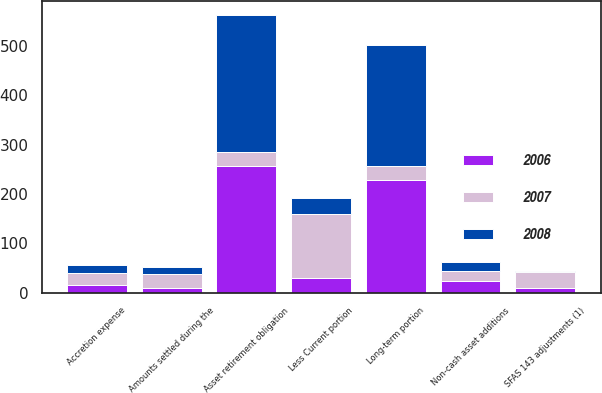Convert chart to OTSL. <chart><loc_0><loc_0><loc_500><loc_500><stacked_bar_chart><ecel><fcel>Asset retirement obligation<fcel>Non-cash asset additions<fcel>SFAS 143 adjustments (1)<fcel>Amounts settled during the<fcel>Accretion expense<fcel>Less Current portion<fcel>Long-term portion<nl><fcel>2007<fcel>28.45<fcel>20.5<fcel>32.6<fcel>27.9<fcel>23.9<fcel>130.6<fcel>28.45<nl><fcel>2008<fcel>277.7<fcel>19.5<fcel>1.8<fcel>14.7<fcel>17.1<fcel>32.6<fcel>245.1<nl><fcel>2006<fcel>257.6<fcel>22.8<fcel>10<fcel>10.4<fcel>15.7<fcel>29<fcel>228.6<nl></chart> 